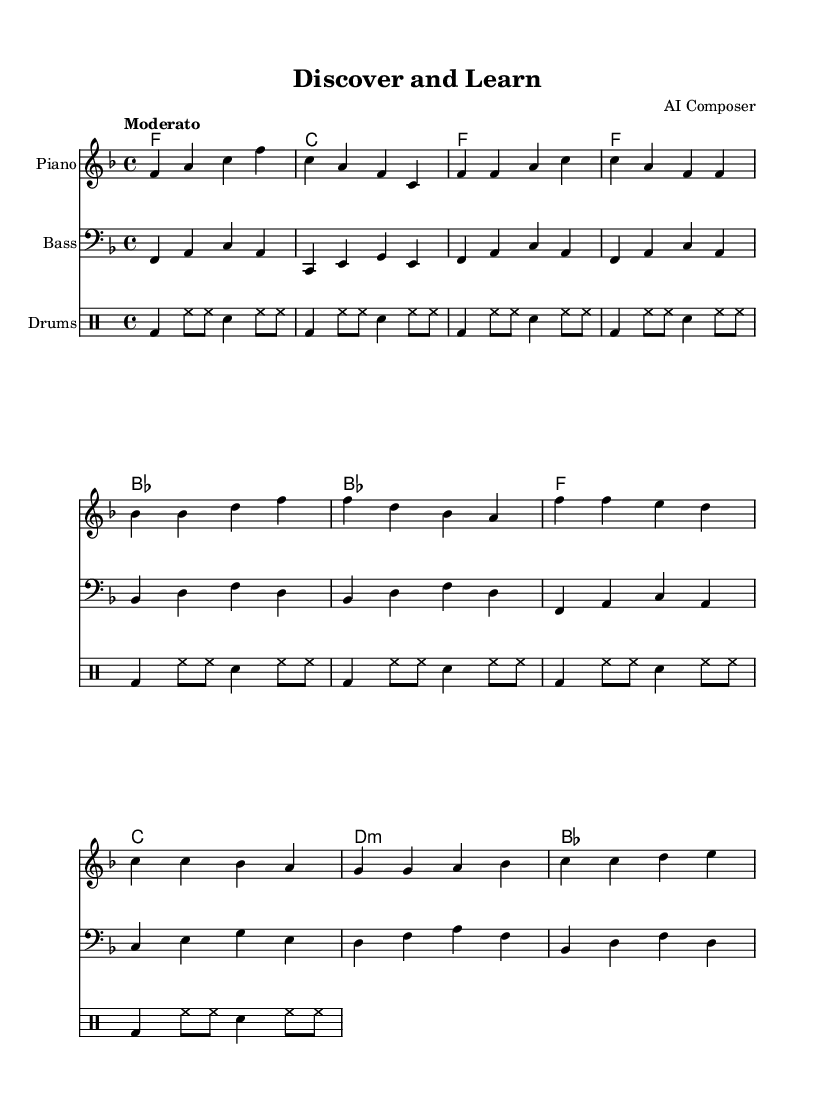What is the key signature of this music? The key signature is indicated at the beginning of the music sheet. Looking at the key signature signs, there is one flat, which corresponds to the key of F major.
Answer: F major What is the time signature of this music? The time signature is shown right after the key signature at the beginning of the music sheet. It displays "4/4," meaning there are four beats in a measure, and a quarter note gets one beat.
Answer: 4/4 What is the tempo marking of the piece? The tempo marking is found at the start of the music, typically above the staff. In this piece, it reads "Moderato," indicating a moderate speed suitable for the overall feel of the song.
Answer: Moderato How many measures are in the verse section? To find the number of measures in the verse, we count the bars in the verse section as indicated in the melody. The verse consists of four measures in total.
Answer: Four What is the main theme of the lyrics in the chorus? The chorus lyrics are analyzed for their thematic elements. The main theme discusses the joy of discovery and learning, emphasizing the power of knowledge and guidance from teachers and technology.
Answer: Joy of discovery Which harmonic chord is used in the chorus? The harmonic chords listed above the melody reveal that the chorus uses specific chords. The chords for the chorus are F, C, D minor, and B flat, indicating a standard progression for a soulful sound.
Answer: F, C, D minor, B flat What instrument plays the bass part in this piece? The instrument name is listed above the staff where the bass part is notated. It clearly states "Bass," indicating that this part is performed on the bass instrument.
Answer: Bass 